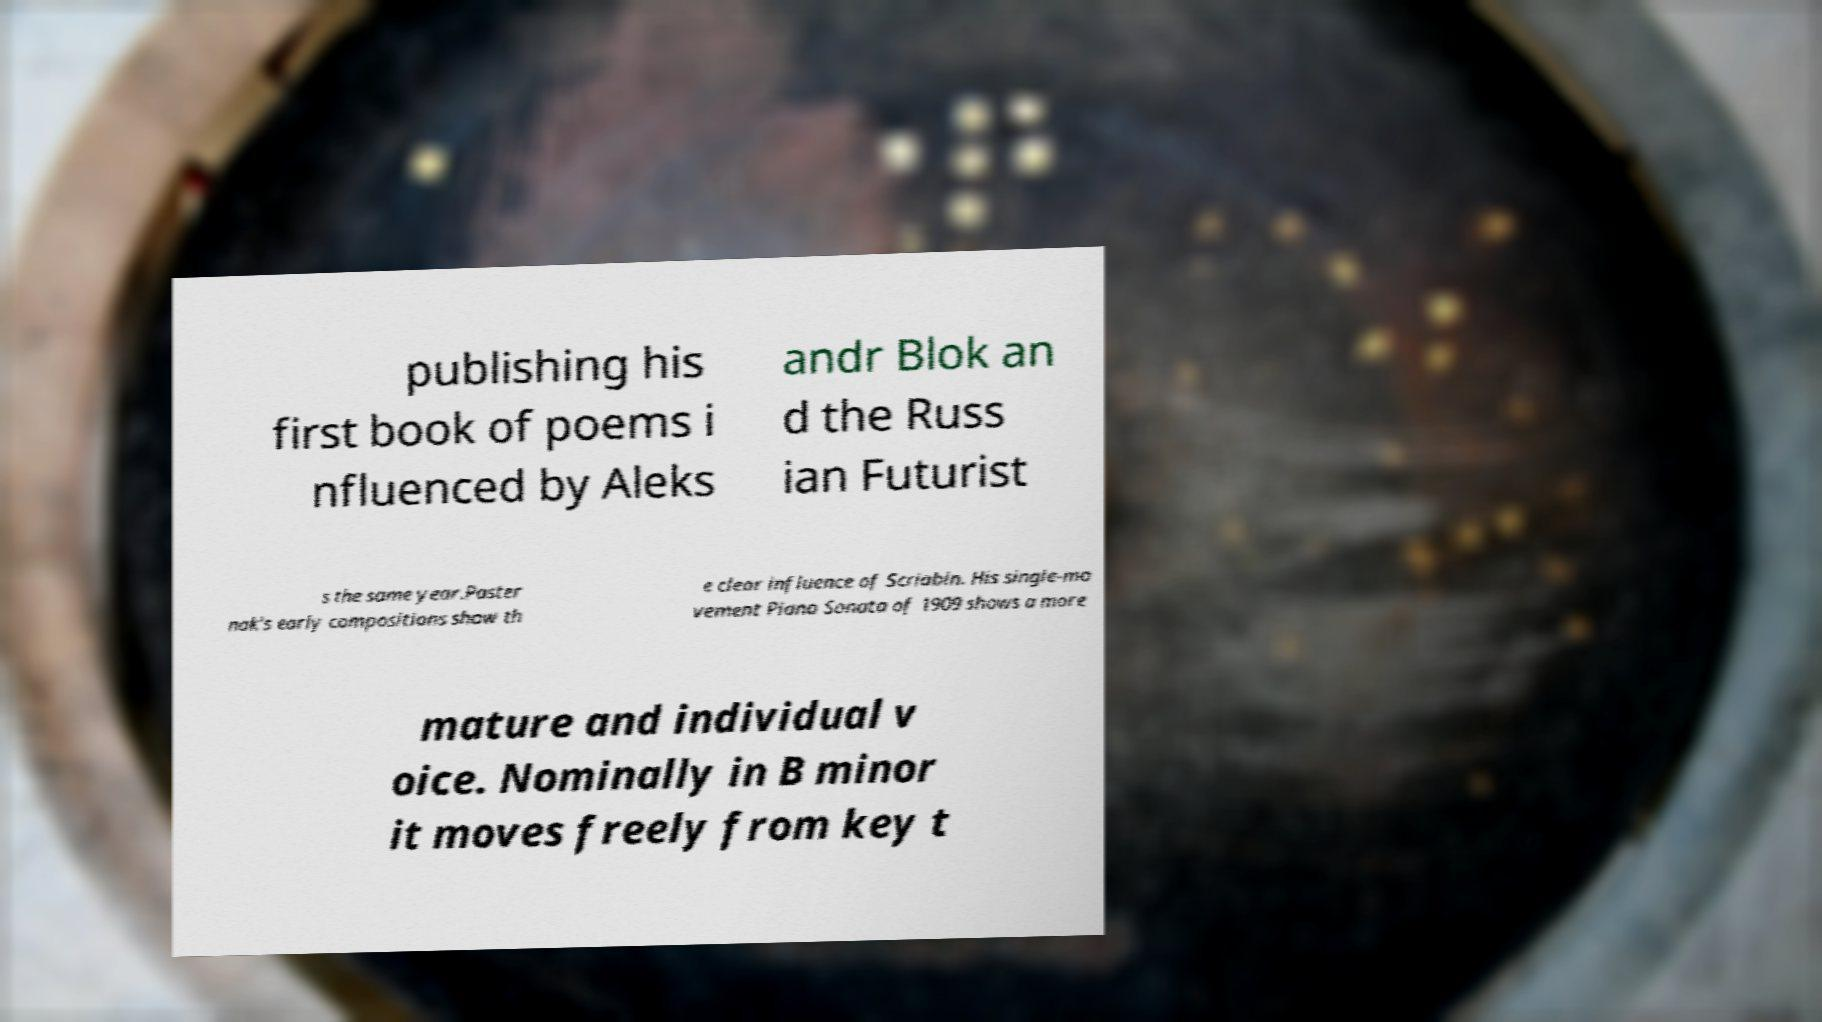Could you assist in decoding the text presented in this image and type it out clearly? publishing his first book of poems i nfluenced by Aleks andr Blok an d the Russ ian Futurist s the same year.Paster nak's early compositions show th e clear influence of Scriabin. His single-mo vement Piano Sonata of 1909 shows a more mature and individual v oice. Nominally in B minor it moves freely from key t 